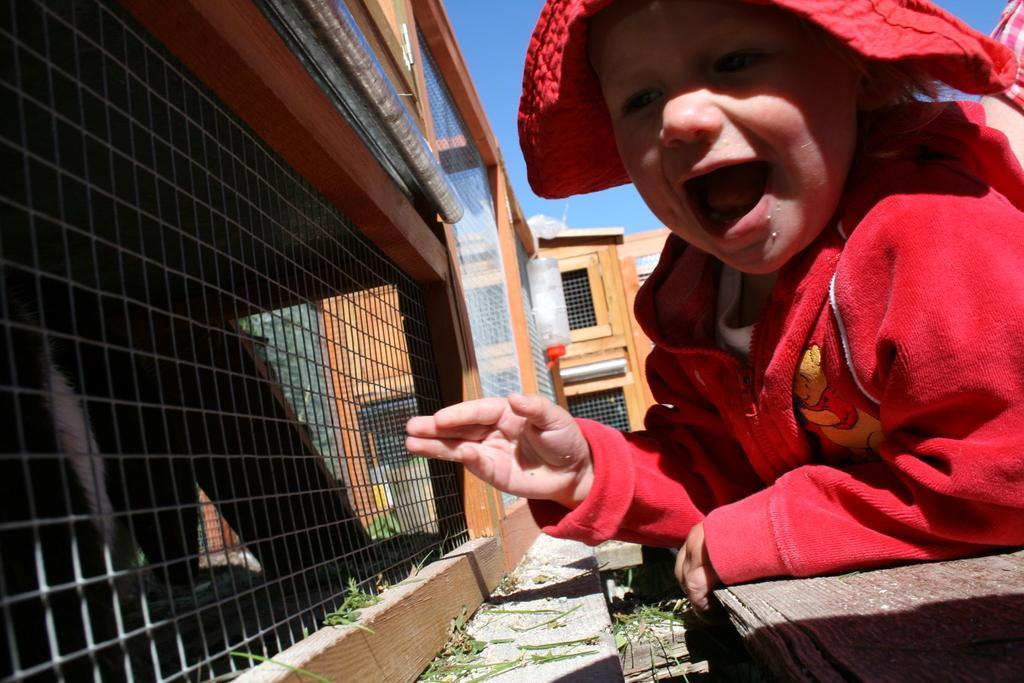Can you describe this image briefly? In this image there is a kid sitting on the wooden plank. In front of the kid there is a cage. In the background there is a bottle which is hanged to the grill. At the top there is sky. 